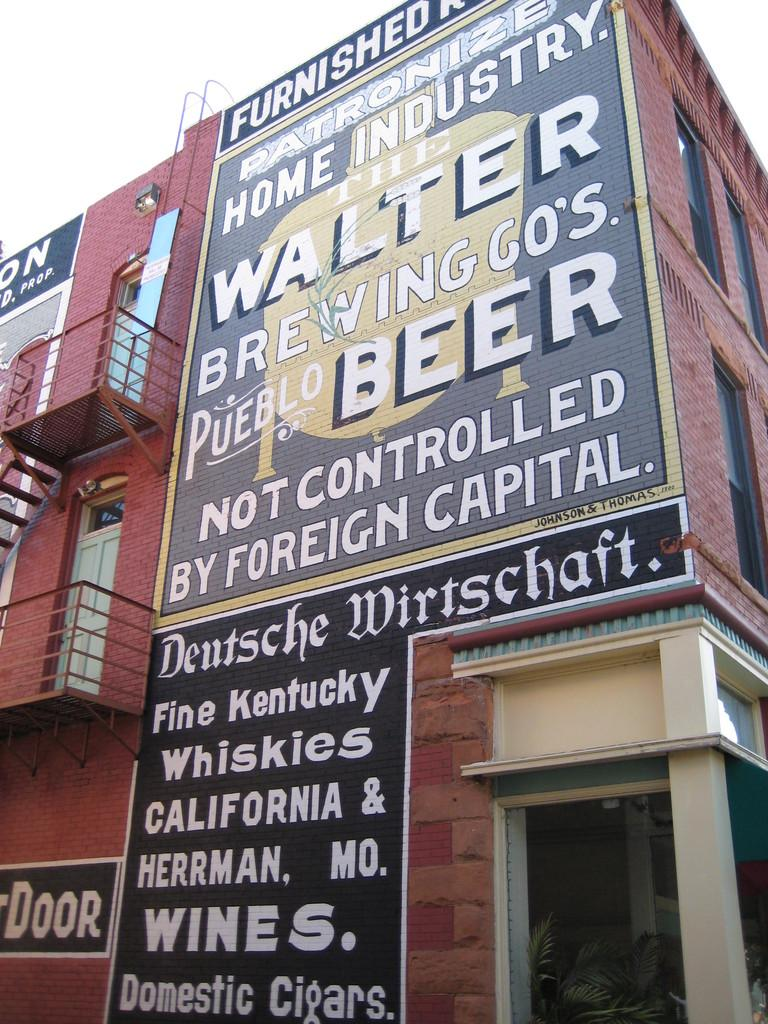What type of structure can be seen in the image? There is a building in the image. What architectural feature is present in the image? Railings are present in the image. What type of vegetation is in the image? There is a plant in the image. What structural element can be seen in the image? A pillar is visible in the image. What type of material is present in the image? Boards are present in the image. What part of the natural environment is visible in the image? The sky is visible in the image. What can be seen in the image? There are objects in the image. Is there any text or writing in the image? Something is written on the building and boards. What is the argument about in the image? There is no argument present in the image. What is the taste of the plant in the image? The taste of the plant cannot be determined from the image, as plants do not have a taste. 